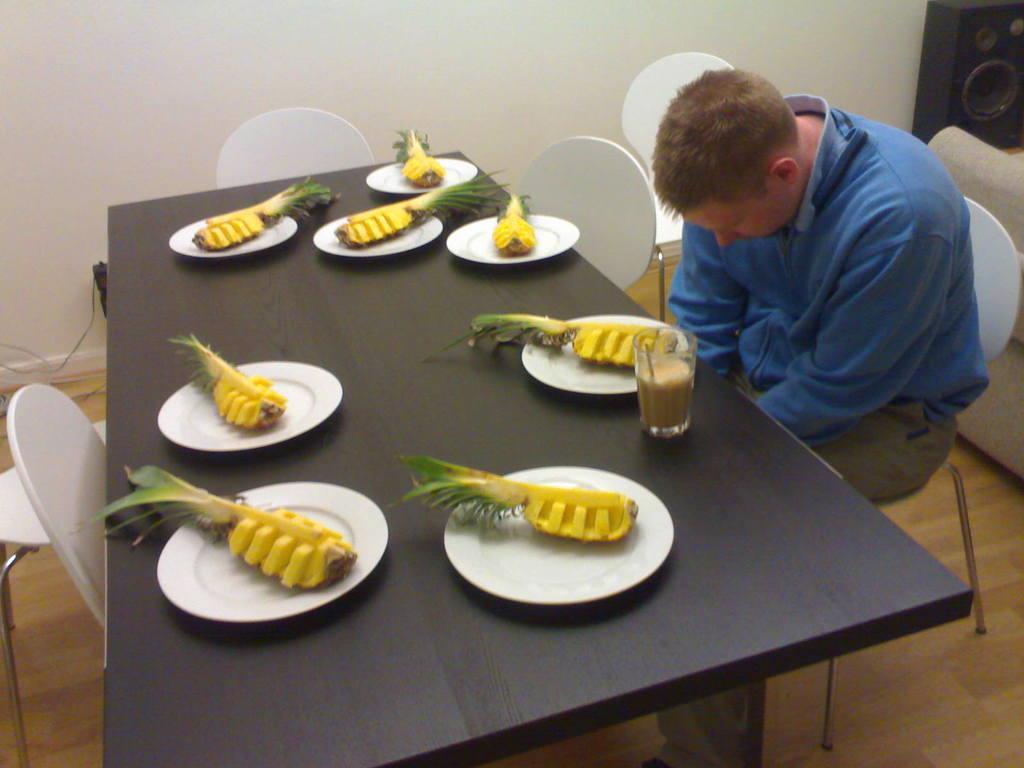Could you give a brief overview of what you see in this image? This picture is clicked inside the room. In front of the image, we see a brown table on which eight plates containing half of the pineapple are placed on this table and even a glass with liquid is also placed on the table. On the the left corner of the picture, we see man in blue jacket is sitting on the chair. Behind him, we see a sofa and a speaker. 